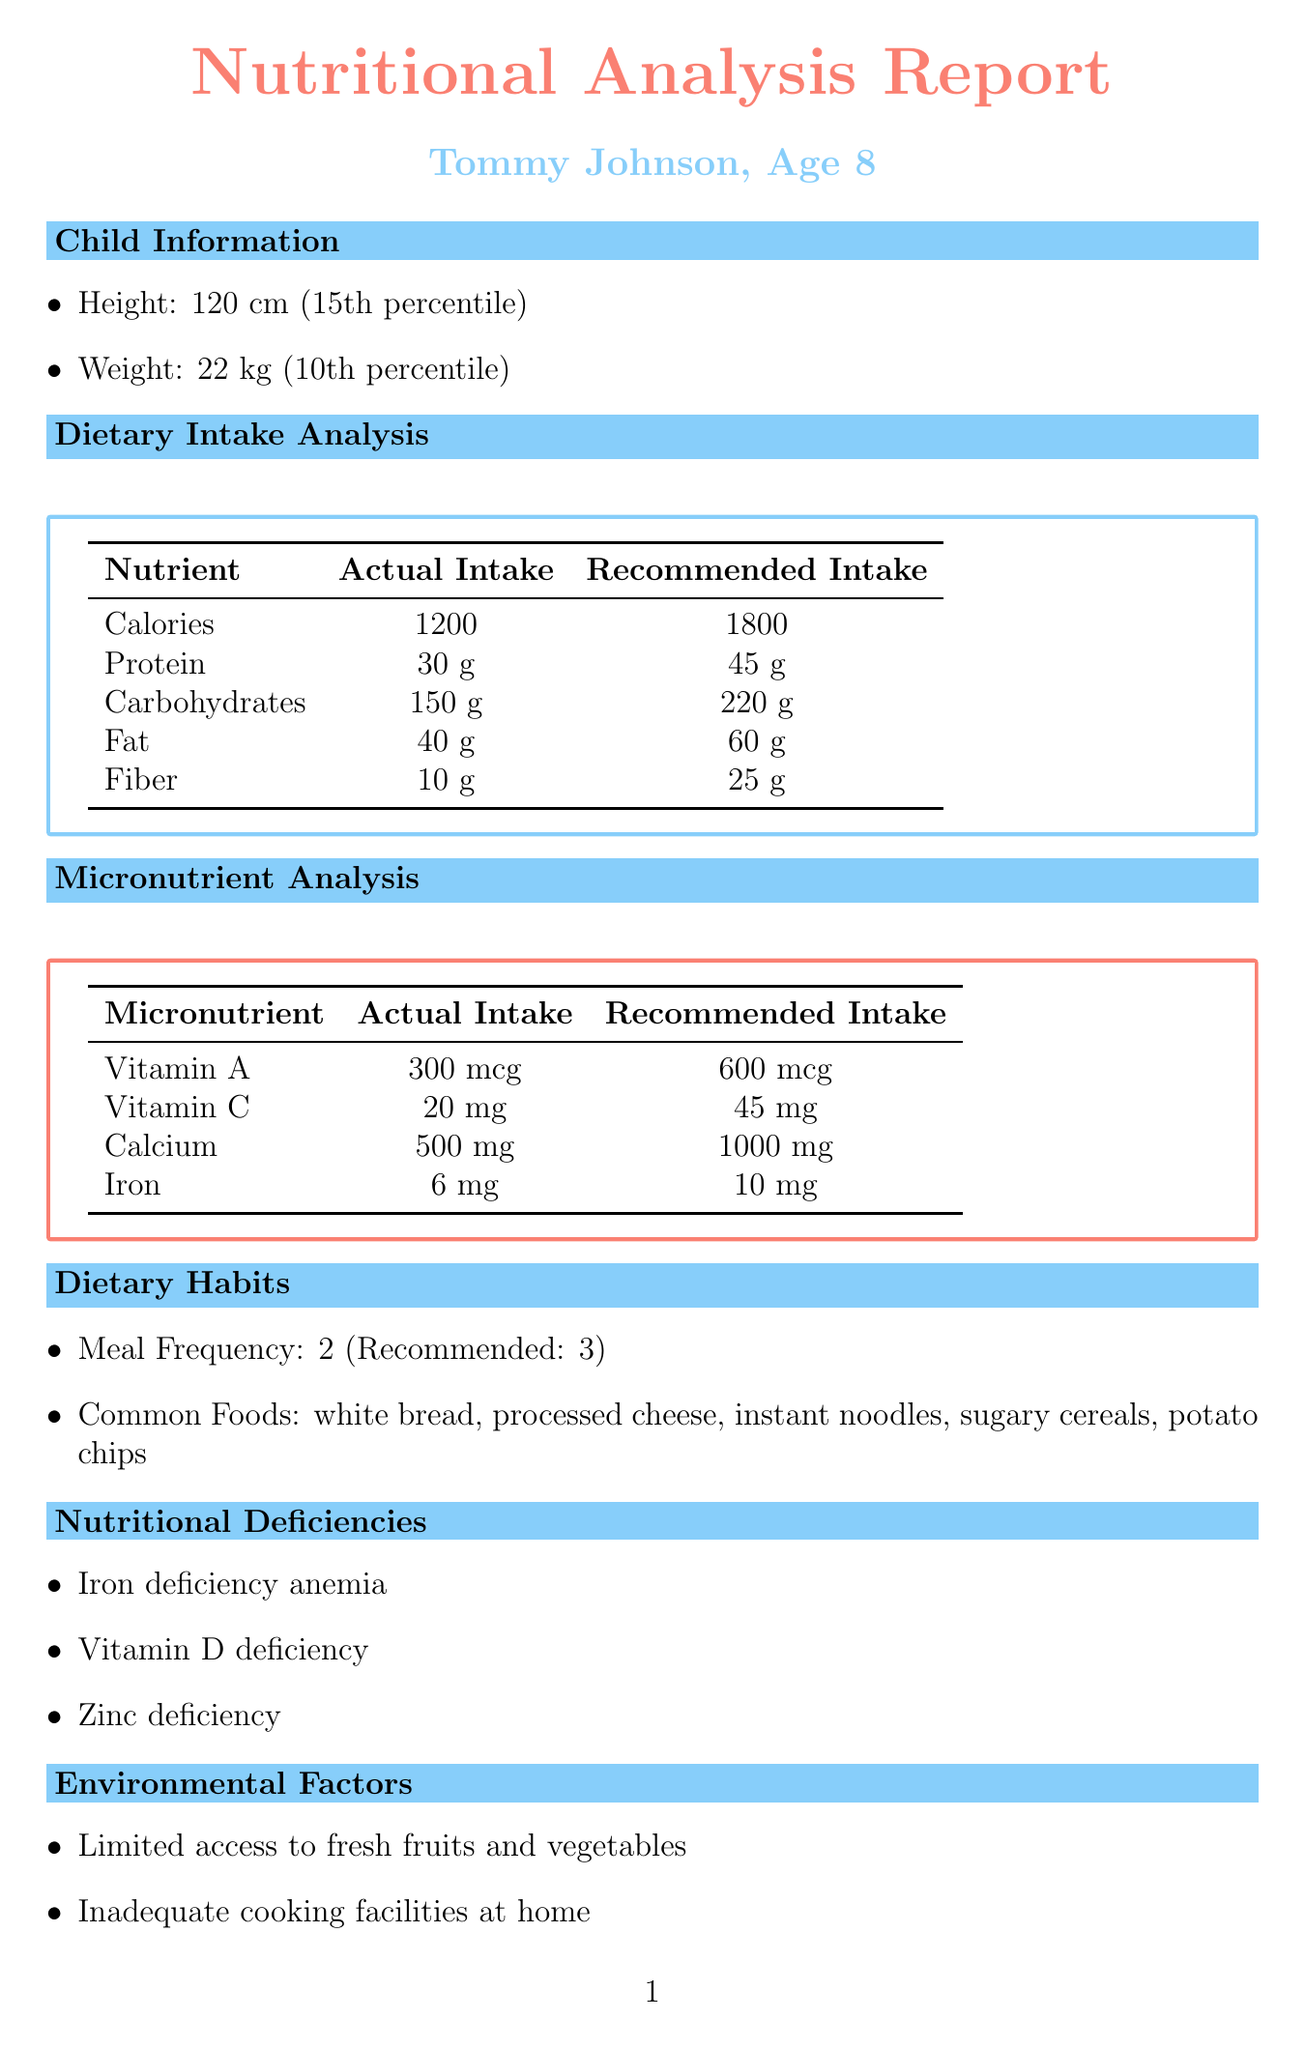What is the child's height? The child's height is specified in the document as 120 cm.
Answer: 120 cm What is the actual intake of protein? The document lists the actual intake of protein as 30 grams.
Answer: 30 g What is the recommended daily calorie intake? The recommended daily calorie intake is noted as 1800 calories in the dietary analysis.
Answer: 1800 How many meals does the child currently have? The document states the current meal frequency is 2 meals.
Answer: 2 Which micronutrient has an actual intake of 500 mg? According to the document, calcium has an actual intake of 500 mg.
Answer: Calcium What deficiencies is the child experiencing? The document lists the nutritional deficiencies as iron deficiency anemia, vitamin D deficiency, and zinc deficiency.
Answer: Iron deficiency anemia, vitamin D deficiency, zinc deficiency What percentile is the child's weight? The child's weight percentile is provided as the 10th percentile in the growth indicators section.
Answer: 10th What is one recommended intervention for the child? The document suggests enrollment in a school meal program as a recommended intervention.
Answer: Enrollment in school meal program What are the long-term risks associated with the child's current nutrition? The document enumerates long-term risks such as stunted growth and cognitive development delays.
Answer: Stunted growth, cognitive development delays 